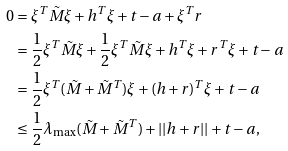Convert formula to latex. <formula><loc_0><loc_0><loc_500><loc_500>0 & = \xi ^ { T } \tilde { M } \xi + h ^ { T } \xi + t - a + \xi ^ { T } r \\ & = \frac { 1 } { 2 } \xi ^ { T } \tilde { M } \xi + \frac { 1 } { 2 } \xi ^ { T } \tilde { M } \xi + h ^ { T } \xi + r ^ { T } \xi + t - a \\ & = \frac { 1 } { 2 } \xi ^ { T } ( \tilde { M } + \tilde { M } ^ { T } ) \xi + ( h + r ) ^ { T } \xi + t - a \\ & \leq \frac { 1 } { 2 } \lambda _ { \max } ( \tilde { M } + \tilde { M } ^ { T } ) + | | h + r | | + t - a ,</formula> 